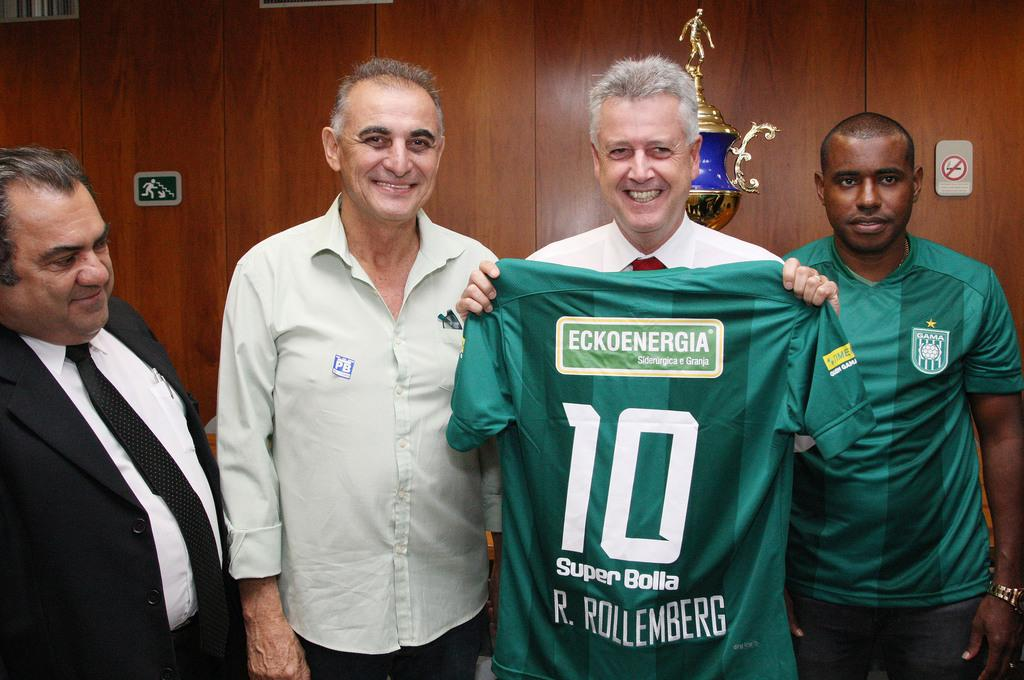<image>
Relay a brief, clear account of the picture shown. smiling men in a conference room hold up a green Super Bolta 10 jersey 